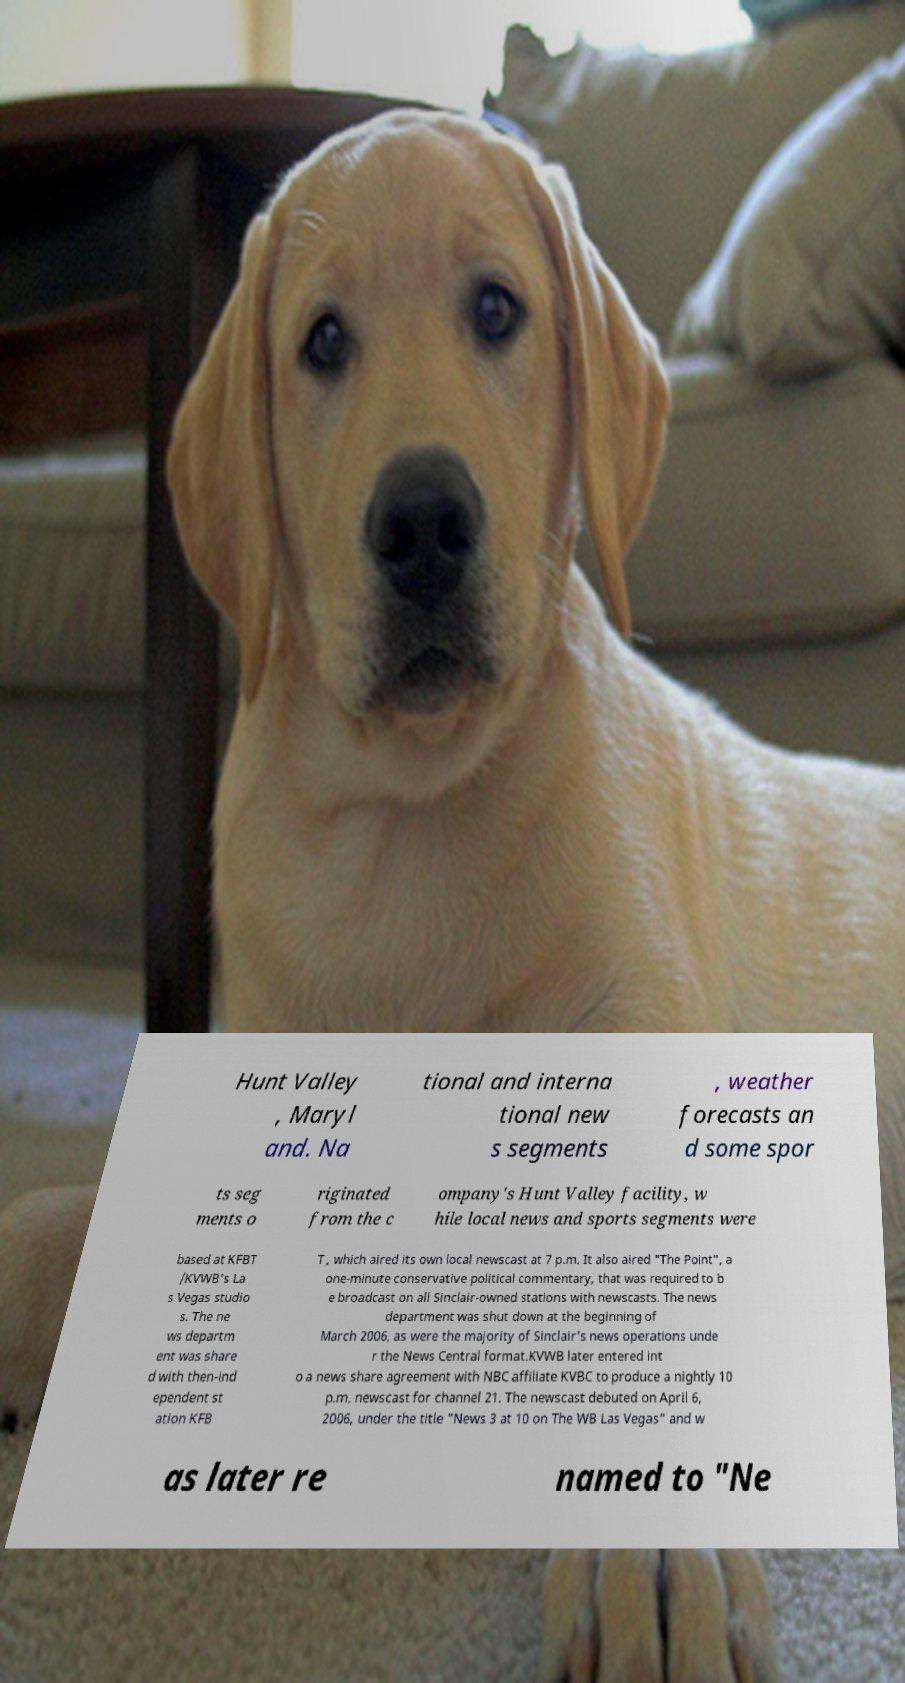What messages or text are displayed in this image? I need them in a readable, typed format. Hunt Valley , Maryl and. Na tional and interna tional new s segments , weather forecasts an d some spor ts seg ments o riginated from the c ompany's Hunt Valley facility, w hile local news and sports segments were based at KFBT /KVWB's La s Vegas studio s. The ne ws departm ent was share d with then-ind ependent st ation KFB T , which aired its own local newscast at 7 p.m. It also aired "The Point", a one-minute conservative political commentary, that was required to b e broadcast on all Sinclair-owned stations with newscasts. The news department was shut down at the beginning of March 2006, as were the majority of Sinclair's news operations unde r the News Central format.KVWB later entered int o a news share agreement with NBC affiliate KVBC to produce a nightly 10 p.m. newscast for channel 21. The newscast debuted on April 6, 2006, under the title "News 3 at 10 on The WB Las Vegas" and w as later re named to "Ne 